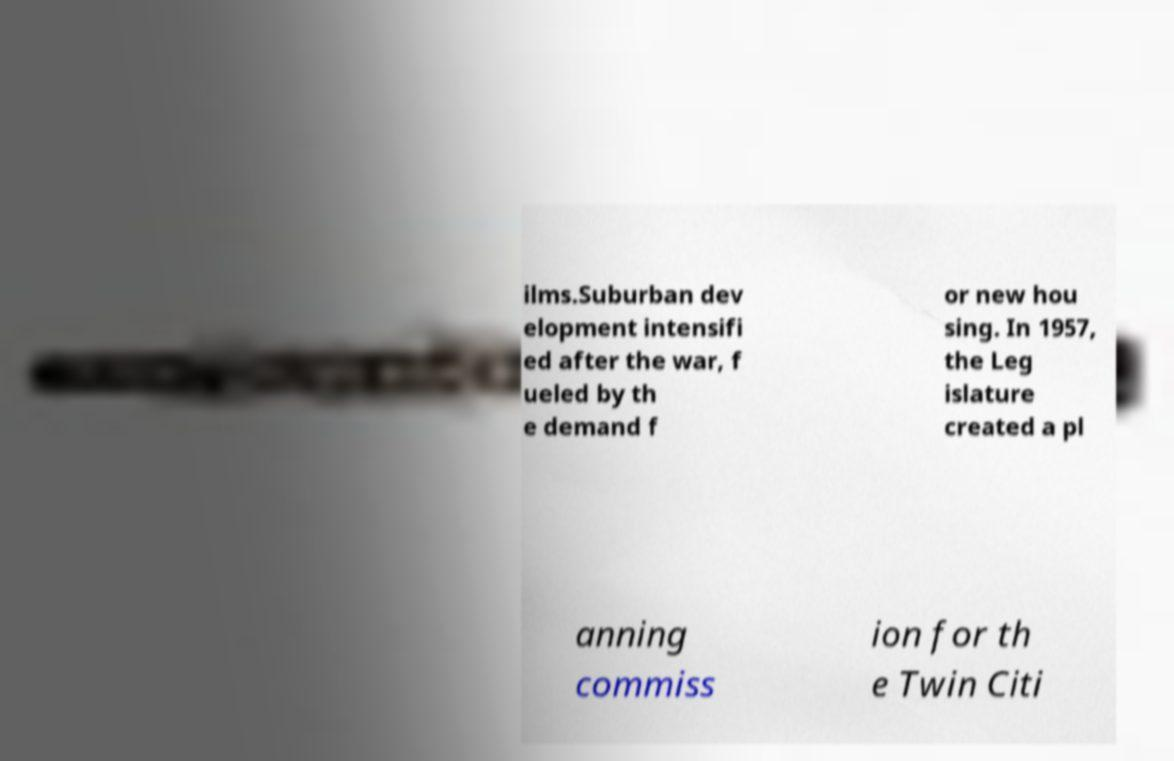For documentation purposes, I need the text within this image transcribed. Could you provide that? ilms.Suburban dev elopment intensifi ed after the war, f ueled by th e demand f or new hou sing. In 1957, the Leg islature created a pl anning commiss ion for th e Twin Citi 